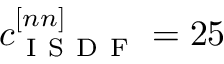Convert formula to latex. <formula><loc_0><loc_0><loc_500><loc_500>c _ { I S D F } ^ { [ n n ] } = 2 5</formula> 